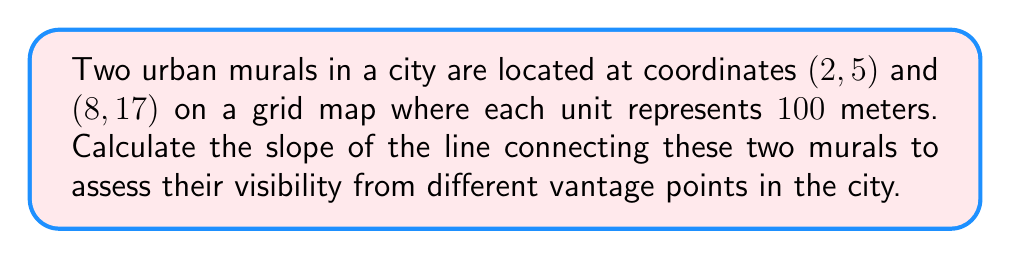Provide a solution to this math problem. To find the slope of the line connecting two points, we use the slope formula:

$$ m = \frac{y_2 - y_1}{x_2 - x_1} $$

Where $(x_1, y_1)$ is the first point and $(x_2, y_2)$ is the second point.

Given:
- Mural 1 is at (2, 5)
- Mural 2 is at (8, 17)

Let's plug these values into the formula:

$$ m = \frac{17 - 5}{8 - 2} $$

Simplify:

$$ m = \frac{12}{6} $$

Reduce the fraction:

$$ m = 2 $$

The slope of 2 means that for every 1 unit increase in x (100 meters horizontally), there is a 2 unit increase in y (200 meters vertically).

This slope can help assess visibility by indicating the rate of elevation change between the murals. A higher slope would suggest a steeper line of sight, which might affect visibility from certain angles in the urban landscape.
Answer: $m = 2$ 